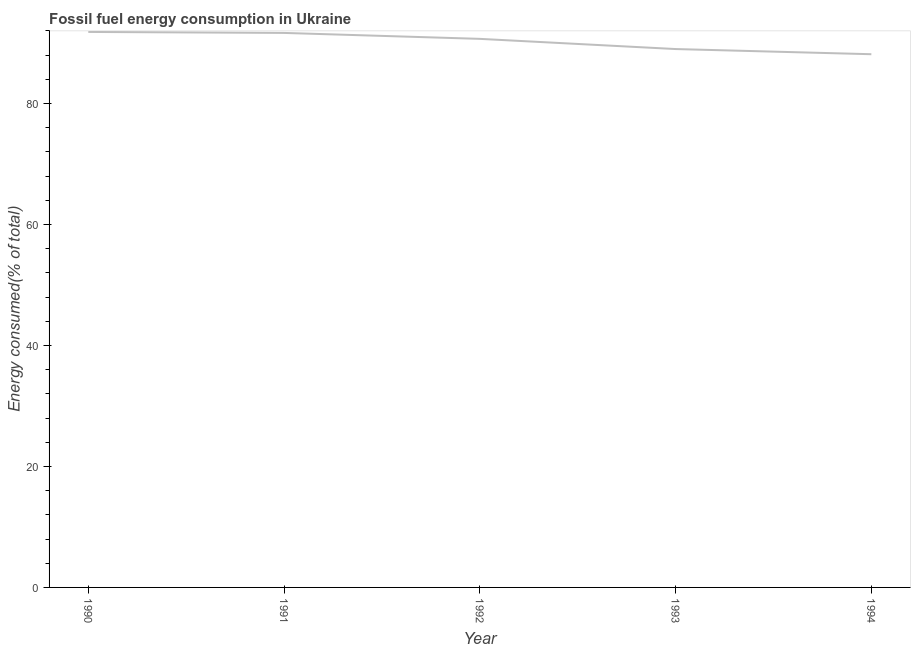What is the fossil fuel energy consumption in 1993?
Give a very brief answer. 89. Across all years, what is the maximum fossil fuel energy consumption?
Your answer should be compact. 91.83. Across all years, what is the minimum fossil fuel energy consumption?
Give a very brief answer. 88.15. What is the sum of the fossil fuel energy consumption?
Provide a short and direct response. 451.33. What is the difference between the fossil fuel energy consumption in 1991 and 1993?
Provide a succinct answer. 2.67. What is the average fossil fuel energy consumption per year?
Ensure brevity in your answer.  90.27. What is the median fossil fuel energy consumption?
Offer a terse response. 90.68. Do a majority of the years between 1990 and 1992 (inclusive) have fossil fuel energy consumption greater than 20 %?
Keep it short and to the point. Yes. What is the ratio of the fossil fuel energy consumption in 1990 to that in 1991?
Your answer should be very brief. 1. Is the fossil fuel energy consumption in 1991 less than that in 1994?
Make the answer very short. No. Is the difference between the fossil fuel energy consumption in 1990 and 1991 greater than the difference between any two years?
Your response must be concise. No. What is the difference between the highest and the second highest fossil fuel energy consumption?
Make the answer very short. 0.16. Is the sum of the fossil fuel energy consumption in 1990 and 1991 greater than the maximum fossil fuel energy consumption across all years?
Your answer should be very brief. Yes. What is the difference between the highest and the lowest fossil fuel energy consumption?
Provide a succinct answer. 3.68. In how many years, is the fossil fuel energy consumption greater than the average fossil fuel energy consumption taken over all years?
Provide a short and direct response. 3. Does the fossil fuel energy consumption monotonically increase over the years?
Make the answer very short. No. How many lines are there?
Make the answer very short. 1. How many years are there in the graph?
Your response must be concise. 5. Does the graph contain any zero values?
Make the answer very short. No. Does the graph contain grids?
Keep it short and to the point. No. What is the title of the graph?
Give a very brief answer. Fossil fuel energy consumption in Ukraine. What is the label or title of the Y-axis?
Your answer should be very brief. Energy consumed(% of total). What is the Energy consumed(% of total) of 1990?
Keep it short and to the point. 91.83. What is the Energy consumed(% of total) of 1991?
Your answer should be very brief. 91.67. What is the Energy consumed(% of total) in 1992?
Your response must be concise. 90.68. What is the Energy consumed(% of total) in 1993?
Offer a terse response. 89. What is the Energy consumed(% of total) in 1994?
Keep it short and to the point. 88.15. What is the difference between the Energy consumed(% of total) in 1990 and 1991?
Provide a succinct answer. 0.16. What is the difference between the Energy consumed(% of total) in 1990 and 1992?
Provide a short and direct response. 1.14. What is the difference between the Energy consumed(% of total) in 1990 and 1993?
Give a very brief answer. 2.83. What is the difference between the Energy consumed(% of total) in 1990 and 1994?
Your response must be concise. 3.68. What is the difference between the Energy consumed(% of total) in 1991 and 1992?
Your answer should be very brief. 0.98. What is the difference between the Energy consumed(% of total) in 1991 and 1993?
Ensure brevity in your answer.  2.67. What is the difference between the Energy consumed(% of total) in 1991 and 1994?
Offer a terse response. 3.52. What is the difference between the Energy consumed(% of total) in 1992 and 1993?
Give a very brief answer. 1.68. What is the difference between the Energy consumed(% of total) in 1992 and 1994?
Give a very brief answer. 2.54. What is the difference between the Energy consumed(% of total) in 1993 and 1994?
Ensure brevity in your answer.  0.85. What is the ratio of the Energy consumed(% of total) in 1990 to that in 1991?
Give a very brief answer. 1. What is the ratio of the Energy consumed(% of total) in 1990 to that in 1993?
Your answer should be very brief. 1.03. What is the ratio of the Energy consumed(% of total) in 1990 to that in 1994?
Offer a terse response. 1.04. What is the ratio of the Energy consumed(% of total) in 1991 to that in 1993?
Your response must be concise. 1.03. What is the ratio of the Energy consumed(% of total) in 1991 to that in 1994?
Provide a short and direct response. 1.04. 